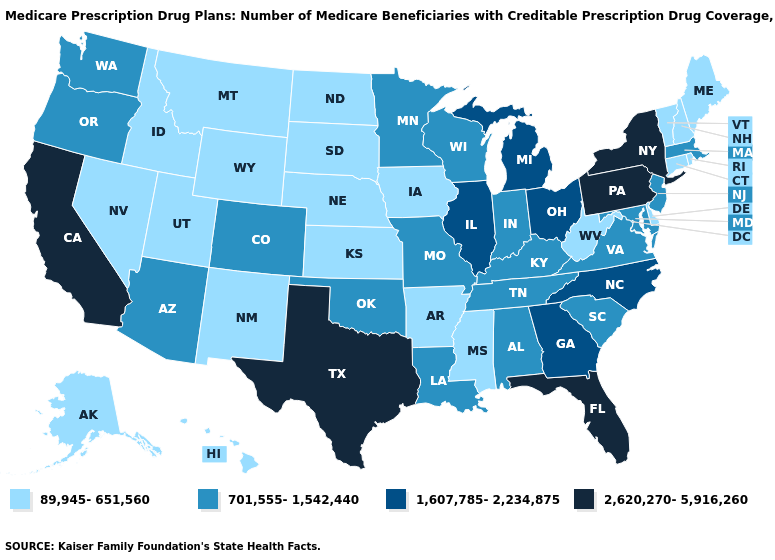What is the highest value in the Northeast ?
Short answer required. 2,620,270-5,916,260. Which states hav the highest value in the West?
Answer briefly. California. Which states have the lowest value in the Northeast?
Give a very brief answer. Connecticut, Maine, New Hampshire, Rhode Island, Vermont. What is the lowest value in states that border Vermont?
Concise answer only. 89,945-651,560. What is the highest value in the MidWest ?
Short answer required. 1,607,785-2,234,875. What is the value of New Mexico?
Concise answer only. 89,945-651,560. What is the lowest value in states that border Arizona?
Short answer required. 89,945-651,560. What is the value of Florida?
Answer briefly. 2,620,270-5,916,260. What is the value of Texas?
Concise answer only. 2,620,270-5,916,260. What is the value of Texas?
Short answer required. 2,620,270-5,916,260. What is the lowest value in the USA?
Give a very brief answer. 89,945-651,560. Which states hav the highest value in the South?
Be succinct. Florida, Texas. What is the value of Colorado?
Be succinct. 701,555-1,542,440. What is the value of Arkansas?
Keep it brief. 89,945-651,560. Does Louisiana have the lowest value in the South?
Give a very brief answer. No. 